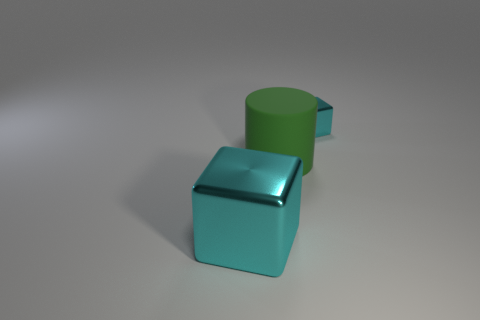Are there the same number of blocks that are behind the big green cylinder and small shiny cylinders?
Your answer should be compact. No. The cylinder that is in front of the metallic object behind the shiny cube on the left side of the matte object is made of what material?
Give a very brief answer. Rubber. The other object that is made of the same material as the tiny object is what shape?
Offer a very short reply. Cube. Is there any other thing of the same color as the large shiny block?
Keep it short and to the point. Yes. There is a cyan metal block that is to the right of the cyan thing on the left side of the tiny cyan shiny thing; how many tiny cyan metal blocks are in front of it?
Give a very brief answer. 0. How many cyan objects are rubber cylinders or blocks?
Make the answer very short. 2. There is a rubber object; does it have the same size as the cyan shiny thing behind the large cyan shiny block?
Offer a very short reply. No. What is the material of the tiny cyan object that is the same shape as the big cyan object?
Ensure brevity in your answer.  Metal. What is the shape of the metal thing that is left of the cyan metallic block behind the metal thing left of the big green object?
Your response must be concise. Cube. How many things are big metallic objects or blocks on the left side of the big cylinder?
Provide a short and direct response. 1. 